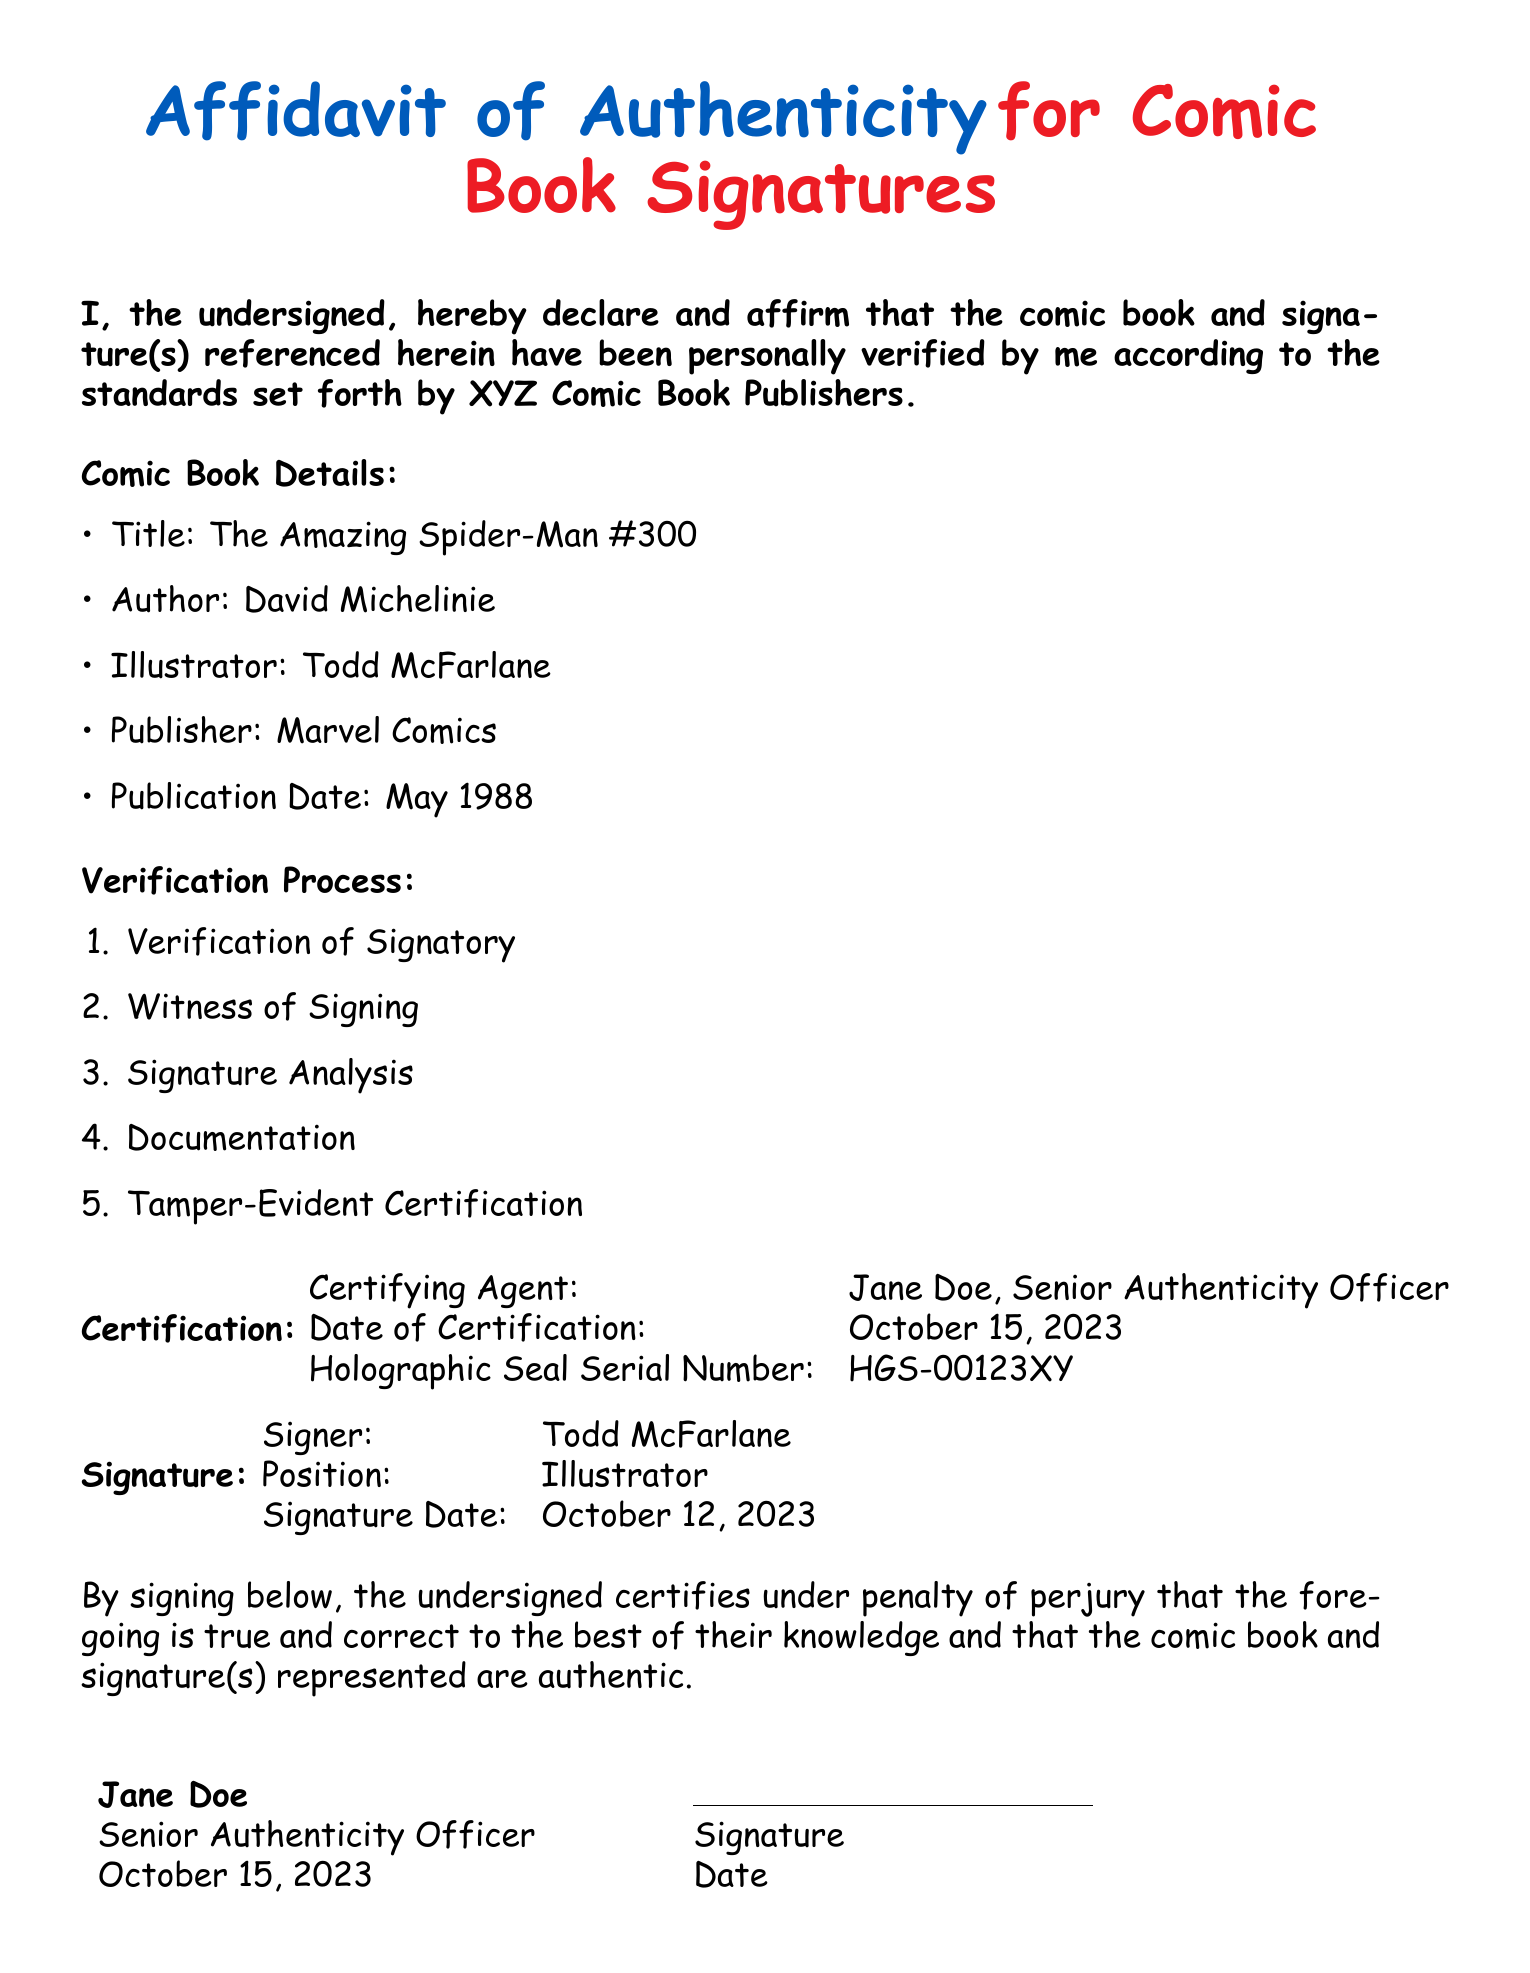What is the title of the comic book? The title is clearly stated in the document under Comic Book Details.
Answer: The Amazing Spider-Man #300 Who is the author of the comic book? The author is also listed in the Comic Book Details section of the document.
Answer: David Michelinie What is the publication date of the comic book? The publication date can be found in the Comic Book Details section.
Answer: May 1988 Who certified the authenticity of the signatures? The certifying agent's name is present in the Certification section.
Answer: Jane Doe What is the holographic seal serial number? The serial number is specifically mentioned in the Certification section.
Answer: HGS-00123XY How many steps are in the verification process? The number of steps can be counted in the Verification Process listed in the document.
Answer: 5 What date was the certification done? The certification date is provided in the Certification section of the document.
Answer: October 15, 2023 What is the position of the signer? The position is mentioned under the Signature section of the document.
Answer: Illustrator Who witnessed the signing according to the verification process? The verification process mentions witnessing, looking for specific identification here.
Answer: (The document does not specify a witness, so it indicates a requirement for the general process.) 